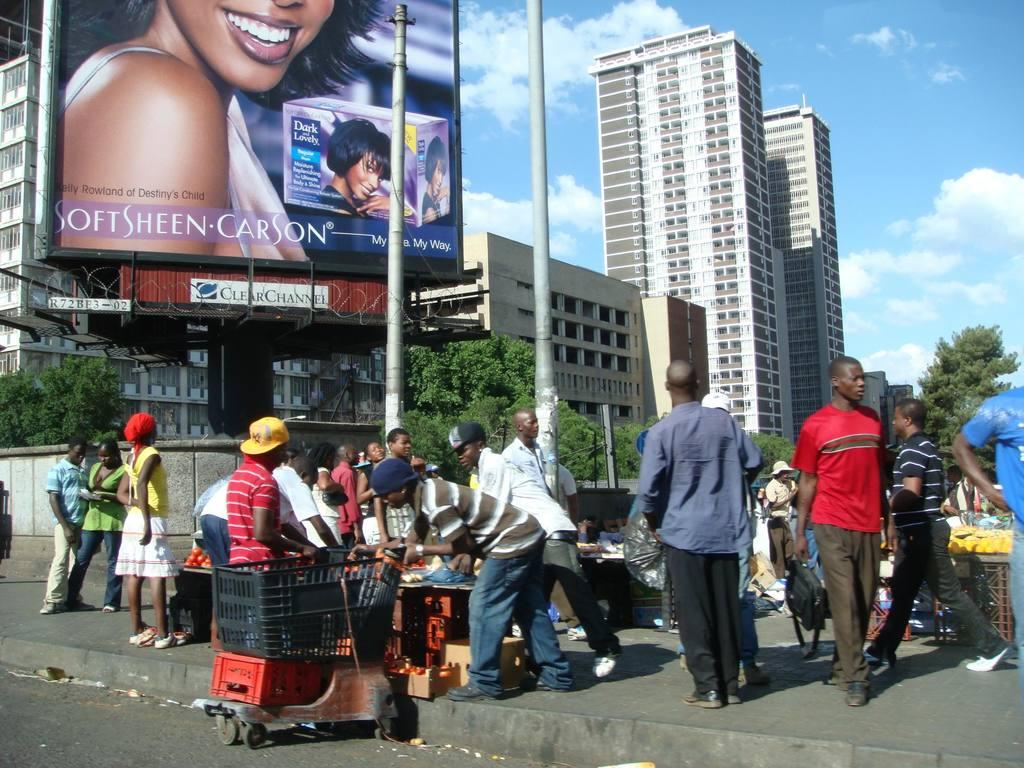What is happening in the center of the image? There are many persons standing on a footpath in the center of the image. What can be seen in the background of the image? There are buildings, advertisement boards, and trees in the background of the image. What type of bed is visible in the image? There is no bed present in the image. How does the growth of the trees affect the advertisement boards in the image? There is no information about the growth of the trees or its effect on the advertisement boards in the image. 